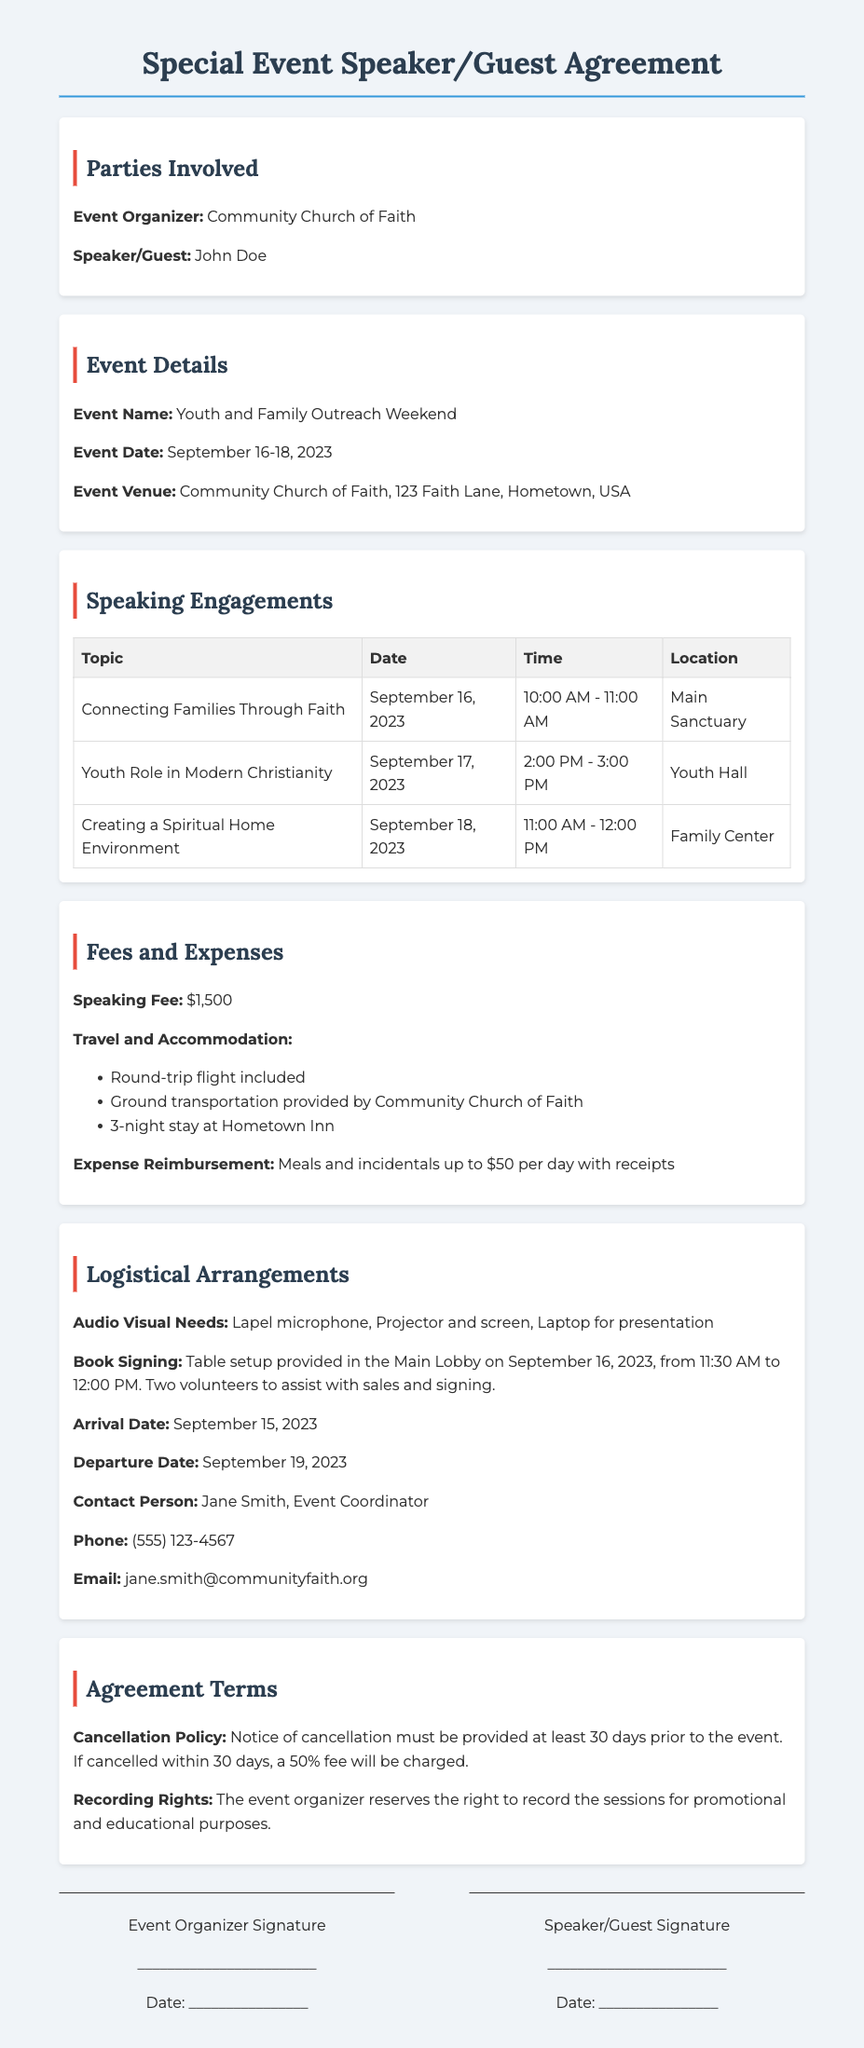What is the name of the event? The event name is stated in the document under Event Details.
Answer: Youth and Family Outreach Weekend Who is the speaker for the event? The speaker's name is listed in the document under Parties Involved.
Answer: John Doe What is the speaking fee amount? The speaking fee is outlined in the Fees and Expenses section.
Answer: $1,500 On what date is the topic "Youth Role in Modern Christianity" scheduled? The date for that topic is provided in the Speaking Engagements table.
Answer: September 17, 2023 What is the cancellation policy? The cancellation policy details are mentioned in the Agreement Terms section.
Answer: Notice of cancellation must be provided at least 30 days prior to the event How many nights will the speaker stay at the hotel? The document specifies the accommodation arrangement in the Fees and Expenses section.
Answer: 3-night stay What is included in the audio-visual needs? The audio-visual requirements are listed in the Logistical Arrangements section.
Answer: Lapel microphone, Projector and screen, Laptop for presentation Who should be contacted for event coordination? The contact person for logistics is identified in the Logistical Arrangements section.
Answer: Jane Smith What is the contact phone number for the event coordinator? The phone number is provided along with the coordinator's details in the Logistical Arrangements section.
Answer: (555) 123-4567 